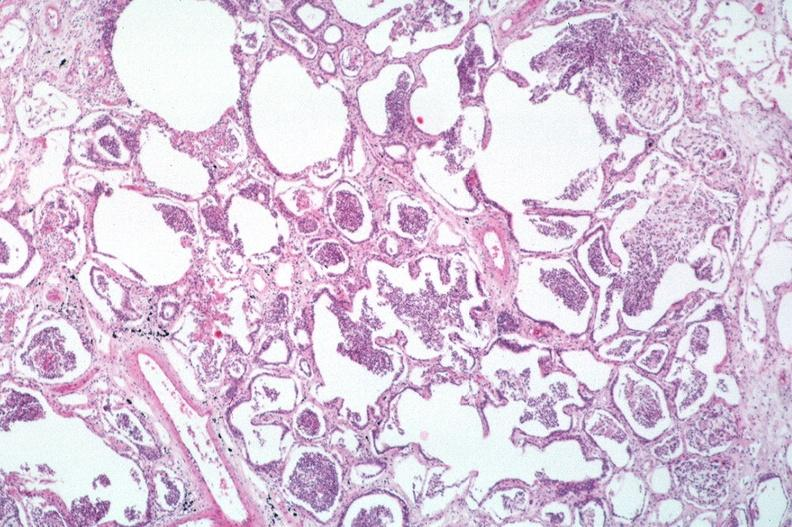what is present?
Answer the question using a single word or phrase. Respiratory 